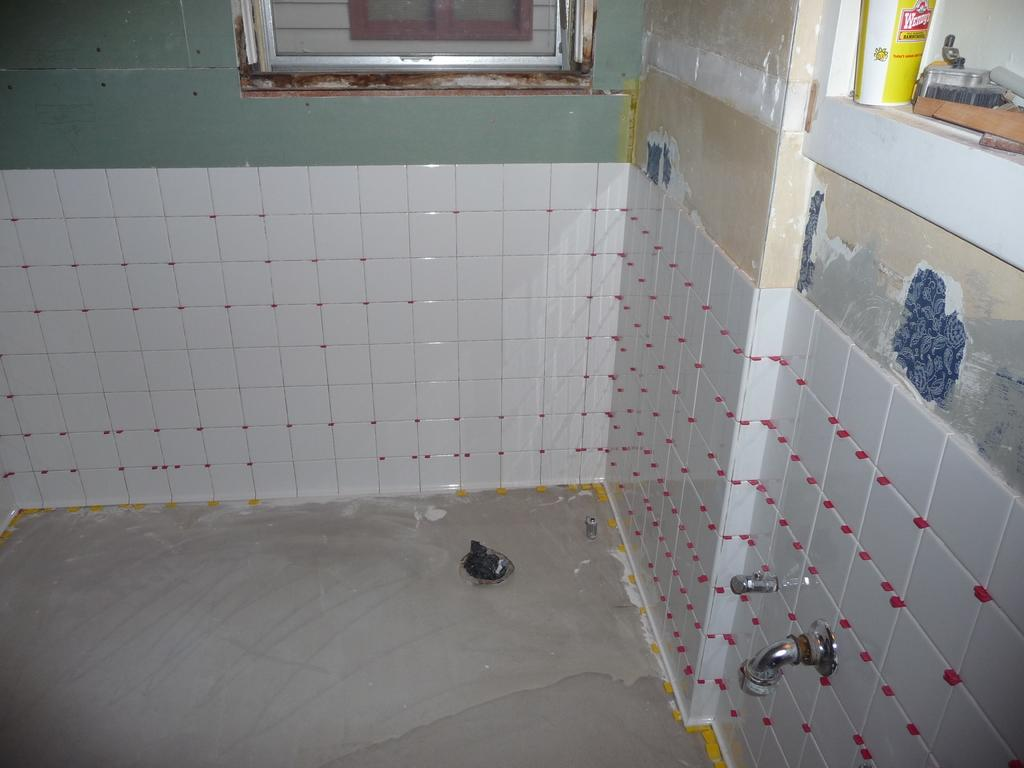What type of room is depicted in the image? The image is of a washroom. What can be seen on the wall in the image? There are taps on the wall in the image. Is there any source of natural light in the image? Yes, there is a window in the image. What is present on the shelf in the image? There are items on a shelf in the image. What channel is the brother watching on the TV in the image? There is no TV or brother present in the image; it is a washroom with taps, a window, and items on a shelf. 